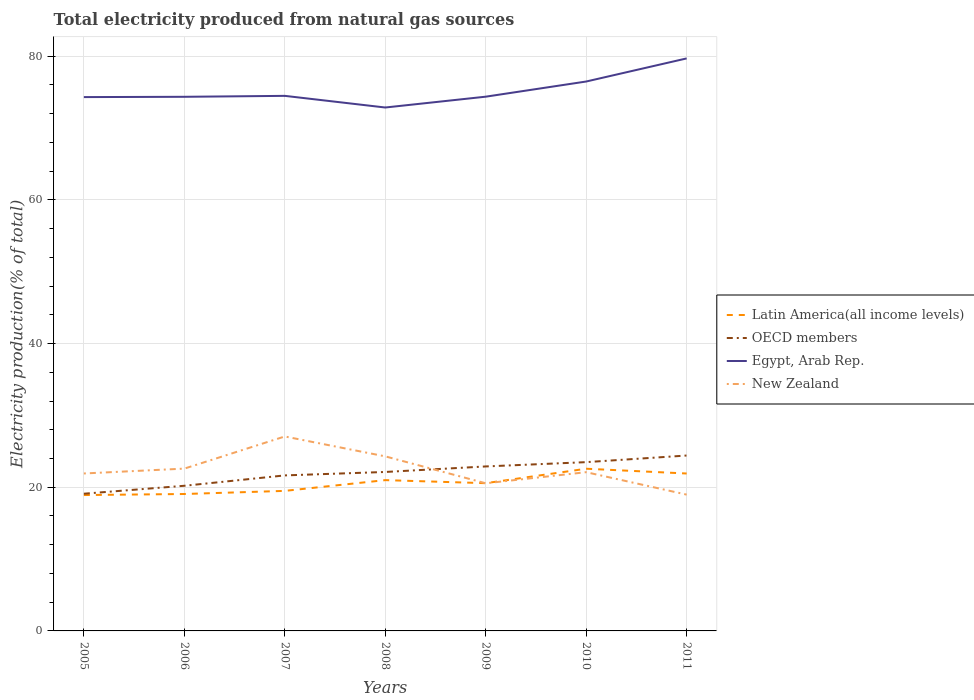Does the line corresponding to OECD members intersect with the line corresponding to Latin America(all income levels)?
Provide a short and direct response. No. Is the number of lines equal to the number of legend labels?
Give a very brief answer. Yes. Across all years, what is the maximum total electricity produced in OECD members?
Provide a succinct answer. 19.1. What is the total total electricity produced in New Zealand in the graph?
Offer a terse response. 2.77. What is the difference between the highest and the second highest total electricity produced in New Zealand?
Offer a terse response. 8.1. What is the difference between the highest and the lowest total electricity produced in Egypt, Arab Rep.?
Keep it short and to the point. 2. How many years are there in the graph?
Your response must be concise. 7. What is the difference between two consecutive major ticks on the Y-axis?
Offer a terse response. 20. Does the graph contain any zero values?
Provide a short and direct response. No. Where does the legend appear in the graph?
Make the answer very short. Center right. How many legend labels are there?
Provide a succinct answer. 4. What is the title of the graph?
Offer a very short reply. Total electricity produced from natural gas sources. Does "Hungary" appear as one of the legend labels in the graph?
Ensure brevity in your answer.  No. What is the label or title of the X-axis?
Provide a succinct answer. Years. What is the label or title of the Y-axis?
Give a very brief answer. Electricity production(% of total). What is the Electricity production(% of total) of Latin America(all income levels) in 2005?
Your answer should be compact. 18.91. What is the Electricity production(% of total) in OECD members in 2005?
Give a very brief answer. 19.1. What is the Electricity production(% of total) in Egypt, Arab Rep. in 2005?
Provide a short and direct response. 74.31. What is the Electricity production(% of total) in New Zealand in 2005?
Your answer should be compact. 21.92. What is the Electricity production(% of total) of Latin America(all income levels) in 2006?
Offer a terse response. 19.06. What is the Electricity production(% of total) of OECD members in 2006?
Offer a very short reply. 20.2. What is the Electricity production(% of total) of Egypt, Arab Rep. in 2006?
Keep it short and to the point. 74.35. What is the Electricity production(% of total) in New Zealand in 2006?
Ensure brevity in your answer.  22.59. What is the Electricity production(% of total) in Latin America(all income levels) in 2007?
Ensure brevity in your answer.  19.49. What is the Electricity production(% of total) in OECD members in 2007?
Your response must be concise. 21.65. What is the Electricity production(% of total) in Egypt, Arab Rep. in 2007?
Your response must be concise. 74.48. What is the Electricity production(% of total) of New Zealand in 2007?
Offer a terse response. 27.07. What is the Electricity production(% of total) in Latin America(all income levels) in 2008?
Ensure brevity in your answer.  20.99. What is the Electricity production(% of total) of OECD members in 2008?
Provide a succinct answer. 22.13. What is the Electricity production(% of total) of Egypt, Arab Rep. in 2008?
Your answer should be very brief. 72.86. What is the Electricity production(% of total) of New Zealand in 2008?
Offer a very short reply. 24.3. What is the Electricity production(% of total) of Latin America(all income levels) in 2009?
Provide a succinct answer. 20.57. What is the Electricity production(% of total) in OECD members in 2009?
Make the answer very short. 22.9. What is the Electricity production(% of total) in Egypt, Arab Rep. in 2009?
Provide a succinct answer. 74.37. What is the Electricity production(% of total) of New Zealand in 2009?
Provide a short and direct response. 20.55. What is the Electricity production(% of total) of Latin America(all income levels) in 2010?
Make the answer very short. 22.58. What is the Electricity production(% of total) in OECD members in 2010?
Your answer should be very brief. 23.49. What is the Electricity production(% of total) of Egypt, Arab Rep. in 2010?
Provide a succinct answer. 76.48. What is the Electricity production(% of total) of New Zealand in 2010?
Offer a terse response. 22.1. What is the Electricity production(% of total) in Latin America(all income levels) in 2011?
Keep it short and to the point. 21.91. What is the Electricity production(% of total) of OECD members in 2011?
Keep it short and to the point. 24.42. What is the Electricity production(% of total) in Egypt, Arab Rep. in 2011?
Keep it short and to the point. 79.69. What is the Electricity production(% of total) of New Zealand in 2011?
Keep it short and to the point. 18.97. Across all years, what is the maximum Electricity production(% of total) in Latin America(all income levels)?
Keep it short and to the point. 22.58. Across all years, what is the maximum Electricity production(% of total) of OECD members?
Your answer should be compact. 24.42. Across all years, what is the maximum Electricity production(% of total) in Egypt, Arab Rep.?
Ensure brevity in your answer.  79.69. Across all years, what is the maximum Electricity production(% of total) in New Zealand?
Keep it short and to the point. 27.07. Across all years, what is the minimum Electricity production(% of total) in Latin America(all income levels)?
Make the answer very short. 18.91. Across all years, what is the minimum Electricity production(% of total) of OECD members?
Your response must be concise. 19.1. Across all years, what is the minimum Electricity production(% of total) of Egypt, Arab Rep.?
Keep it short and to the point. 72.86. Across all years, what is the minimum Electricity production(% of total) of New Zealand?
Your response must be concise. 18.97. What is the total Electricity production(% of total) of Latin America(all income levels) in the graph?
Your answer should be compact. 143.51. What is the total Electricity production(% of total) of OECD members in the graph?
Offer a terse response. 153.88. What is the total Electricity production(% of total) of Egypt, Arab Rep. in the graph?
Provide a succinct answer. 526.54. What is the total Electricity production(% of total) in New Zealand in the graph?
Make the answer very short. 157.5. What is the difference between the Electricity production(% of total) of Latin America(all income levels) in 2005 and that in 2006?
Provide a succinct answer. -0.14. What is the difference between the Electricity production(% of total) of OECD members in 2005 and that in 2006?
Provide a succinct answer. -1.11. What is the difference between the Electricity production(% of total) in Egypt, Arab Rep. in 2005 and that in 2006?
Your answer should be compact. -0.04. What is the difference between the Electricity production(% of total) of New Zealand in 2005 and that in 2006?
Make the answer very short. -0.68. What is the difference between the Electricity production(% of total) of Latin America(all income levels) in 2005 and that in 2007?
Give a very brief answer. -0.58. What is the difference between the Electricity production(% of total) of OECD members in 2005 and that in 2007?
Offer a very short reply. -2.55. What is the difference between the Electricity production(% of total) in Egypt, Arab Rep. in 2005 and that in 2007?
Offer a very short reply. -0.17. What is the difference between the Electricity production(% of total) in New Zealand in 2005 and that in 2007?
Keep it short and to the point. -5.15. What is the difference between the Electricity production(% of total) in Latin America(all income levels) in 2005 and that in 2008?
Offer a very short reply. -2.08. What is the difference between the Electricity production(% of total) in OECD members in 2005 and that in 2008?
Give a very brief answer. -3.03. What is the difference between the Electricity production(% of total) in Egypt, Arab Rep. in 2005 and that in 2008?
Keep it short and to the point. 1.45. What is the difference between the Electricity production(% of total) in New Zealand in 2005 and that in 2008?
Offer a very short reply. -2.38. What is the difference between the Electricity production(% of total) of Latin America(all income levels) in 2005 and that in 2009?
Keep it short and to the point. -1.65. What is the difference between the Electricity production(% of total) of OECD members in 2005 and that in 2009?
Your answer should be very brief. -3.8. What is the difference between the Electricity production(% of total) of Egypt, Arab Rep. in 2005 and that in 2009?
Provide a succinct answer. -0.06. What is the difference between the Electricity production(% of total) of New Zealand in 2005 and that in 2009?
Ensure brevity in your answer.  1.37. What is the difference between the Electricity production(% of total) in Latin America(all income levels) in 2005 and that in 2010?
Your answer should be compact. -3.66. What is the difference between the Electricity production(% of total) of OECD members in 2005 and that in 2010?
Offer a very short reply. -4.4. What is the difference between the Electricity production(% of total) in Egypt, Arab Rep. in 2005 and that in 2010?
Your answer should be compact. -2.17. What is the difference between the Electricity production(% of total) in New Zealand in 2005 and that in 2010?
Offer a terse response. -0.18. What is the difference between the Electricity production(% of total) in Latin America(all income levels) in 2005 and that in 2011?
Give a very brief answer. -3. What is the difference between the Electricity production(% of total) in OECD members in 2005 and that in 2011?
Make the answer very short. -5.32. What is the difference between the Electricity production(% of total) of Egypt, Arab Rep. in 2005 and that in 2011?
Keep it short and to the point. -5.39. What is the difference between the Electricity production(% of total) in New Zealand in 2005 and that in 2011?
Your answer should be very brief. 2.94. What is the difference between the Electricity production(% of total) of Latin America(all income levels) in 2006 and that in 2007?
Give a very brief answer. -0.43. What is the difference between the Electricity production(% of total) of OECD members in 2006 and that in 2007?
Provide a succinct answer. -1.44. What is the difference between the Electricity production(% of total) of Egypt, Arab Rep. in 2006 and that in 2007?
Ensure brevity in your answer.  -0.13. What is the difference between the Electricity production(% of total) in New Zealand in 2006 and that in 2007?
Your response must be concise. -4.47. What is the difference between the Electricity production(% of total) in Latin America(all income levels) in 2006 and that in 2008?
Your answer should be compact. -1.93. What is the difference between the Electricity production(% of total) in OECD members in 2006 and that in 2008?
Provide a short and direct response. -1.92. What is the difference between the Electricity production(% of total) of Egypt, Arab Rep. in 2006 and that in 2008?
Keep it short and to the point. 1.49. What is the difference between the Electricity production(% of total) in New Zealand in 2006 and that in 2008?
Provide a short and direct response. -1.71. What is the difference between the Electricity production(% of total) of Latin America(all income levels) in 2006 and that in 2009?
Your response must be concise. -1.51. What is the difference between the Electricity production(% of total) in OECD members in 2006 and that in 2009?
Offer a very short reply. -2.69. What is the difference between the Electricity production(% of total) of Egypt, Arab Rep. in 2006 and that in 2009?
Your answer should be compact. -0.02. What is the difference between the Electricity production(% of total) of New Zealand in 2006 and that in 2009?
Offer a very short reply. 2.04. What is the difference between the Electricity production(% of total) of Latin America(all income levels) in 2006 and that in 2010?
Your answer should be compact. -3.52. What is the difference between the Electricity production(% of total) of OECD members in 2006 and that in 2010?
Your answer should be very brief. -3.29. What is the difference between the Electricity production(% of total) in Egypt, Arab Rep. in 2006 and that in 2010?
Your answer should be very brief. -2.13. What is the difference between the Electricity production(% of total) in New Zealand in 2006 and that in 2010?
Your response must be concise. 0.5. What is the difference between the Electricity production(% of total) of Latin America(all income levels) in 2006 and that in 2011?
Provide a short and direct response. -2.85. What is the difference between the Electricity production(% of total) in OECD members in 2006 and that in 2011?
Give a very brief answer. -4.21. What is the difference between the Electricity production(% of total) in Egypt, Arab Rep. in 2006 and that in 2011?
Provide a short and direct response. -5.34. What is the difference between the Electricity production(% of total) of New Zealand in 2006 and that in 2011?
Ensure brevity in your answer.  3.62. What is the difference between the Electricity production(% of total) in Latin America(all income levels) in 2007 and that in 2008?
Provide a short and direct response. -1.5. What is the difference between the Electricity production(% of total) of OECD members in 2007 and that in 2008?
Keep it short and to the point. -0.48. What is the difference between the Electricity production(% of total) in Egypt, Arab Rep. in 2007 and that in 2008?
Provide a short and direct response. 1.62. What is the difference between the Electricity production(% of total) of New Zealand in 2007 and that in 2008?
Keep it short and to the point. 2.77. What is the difference between the Electricity production(% of total) in Latin America(all income levels) in 2007 and that in 2009?
Offer a terse response. -1.07. What is the difference between the Electricity production(% of total) in OECD members in 2007 and that in 2009?
Your response must be concise. -1.25. What is the difference between the Electricity production(% of total) of Egypt, Arab Rep. in 2007 and that in 2009?
Make the answer very short. 0.11. What is the difference between the Electricity production(% of total) in New Zealand in 2007 and that in 2009?
Give a very brief answer. 6.52. What is the difference between the Electricity production(% of total) in Latin America(all income levels) in 2007 and that in 2010?
Offer a terse response. -3.08. What is the difference between the Electricity production(% of total) of OECD members in 2007 and that in 2010?
Keep it short and to the point. -1.85. What is the difference between the Electricity production(% of total) of Egypt, Arab Rep. in 2007 and that in 2010?
Provide a succinct answer. -2. What is the difference between the Electricity production(% of total) in New Zealand in 2007 and that in 2010?
Provide a succinct answer. 4.97. What is the difference between the Electricity production(% of total) in Latin America(all income levels) in 2007 and that in 2011?
Provide a succinct answer. -2.42. What is the difference between the Electricity production(% of total) of OECD members in 2007 and that in 2011?
Make the answer very short. -2.77. What is the difference between the Electricity production(% of total) in Egypt, Arab Rep. in 2007 and that in 2011?
Keep it short and to the point. -5.21. What is the difference between the Electricity production(% of total) of New Zealand in 2007 and that in 2011?
Provide a short and direct response. 8.1. What is the difference between the Electricity production(% of total) in Latin America(all income levels) in 2008 and that in 2009?
Give a very brief answer. 0.42. What is the difference between the Electricity production(% of total) of OECD members in 2008 and that in 2009?
Keep it short and to the point. -0.77. What is the difference between the Electricity production(% of total) in Egypt, Arab Rep. in 2008 and that in 2009?
Keep it short and to the point. -1.51. What is the difference between the Electricity production(% of total) of New Zealand in 2008 and that in 2009?
Provide a succinct answer. 3.75. What is the difference between the Electricity production(% of total) of Latin America(all income levels) in 2008 and that in 2010?
Offer a terse response. -1.59. What is the difference between the Electricity production(% of total) of OECD members in 2008 and that in 2010?
Offer a terse response. -1.37. What is the difference between the Electricity production(% of total) of Egypt, Arab Rep. in 2008 and that in 2010?
Make the answer very short. -3.62. What is the difference between the Electricity production(% of total) of New Zealand in 2008 and that in 2010?
Keep it short and to the point. 2.2. What is the difference between the Electricity production(% of total) of Latin America(all income levels) in 2008 and that in 2011?
Provide a short and direct response. -0.92. What is the difference between the Electricity production(% of total) in OECD members in 2008 and that in 2011?
Provide a short and direct response. -2.29. What is the difference between the Electricity production(% of total) in Egypt, Arab Rep. in 2008 and that in 2011?
Offer a terse response. -6.83. What is the difference between the Electricity production(% of total) of New Zealand in 2008 and that in 2011?
Offer a very short reply. 5.33. What is the difference between the Electricity production(% of total) of Latin America(all income levels) in 2009 and that in 2010?
Your answer should be very brief. -2.01. What is the difference between the Electricity production(% of total) in OECD members in 2009 and that in 2010?
Give a very brief answer. -0.6. What is the difference between the Electricity production(% of total) of Egypt, Arab Rep. in 2009 and that in 2010?
Your answer should be very brief. -2.11. What is the difference between the Electricity production(% of total) in New Zealand in 2009 and that in 2010?
Your answer should be compact. -1.55. What is the difference between the Electricity production(% of total) of Latin America(all income levels) in 2009 and that in 2011?
Give a very brief answer. -1.35. What is the difference between the Electricity production(% of total) of OECD members in 2009 and that in 2011?
Your response must be concise. -1.52. What is the difference between the Electricity production(% of total) of Egypt, Arab Rep. in 2009 and that in 2011?
Your response must be concise. -5.33. What is the difference between the Electricity production(% of total) of New Zealand in 2009 and that in 2011?
Your answer should be very brief. 1.58. What is the difference between the Electricity production(% of total) in Latin America(all income levels) in 2010 and that in 2011?
Provide a succinct answer. 0.66. What is the difference between the Electricity production(% of total) of OECD members in 2010 and that in 2011?
Your answer should be compact. -0.92. What is the difference between the Electricity production(% of total) of Egypt, Arab Rep. in 2010 and that in 2011?
Give a very brief answer. -3.22. What is the difference between the Electricity production(% of total) in New Zealand in 2010 and that in 2011?
Offer a terse response. 3.12. What is the difference between the Electricity production(% of total) of Latin America(all income levels) in 2005 and the Electricity production(% of total) of OECD members in 2006?
Provide a succinct answer. -1.29. What is the difference between the Electricity production(% of total) of Latin America(all income levels) in 2005 and the Electricity production(% of total) of Egypt, Arab Rep. in 2006?
Keep it short and to the point. -55.44. What is the difference between the Electricity production(% of total) in Latin America(all income levels) in 2005 and the Electricity production(% of total) in New Zealand in 2006?
Your answer should be very brief. -3.68. What is the difference between the Electricity production(% of total) in OECD members in 2005 and the Electricity production(% of total) in Egypt, Arab Rep. in 2006?
Your response must be concise. -55.25. What is the difference between the Electricity production(% of total) in OECD members in 2005 and the Electricity production(% of total) in New Zealand in 2006?
Offer a terse response. -3.49. What is the difference between the Electricity production(% of total) in Egypt, Arab Rep. in 2005 and the Electricity production(% of total) in New Zealand in 2006?
Make the answer very short. 51.72. What is the difference between the Electricity production(% of total) in Latin America(all income levels) in 2005 and the Electricity production(% of total) in OECD members in 2007?
Ensure brevity in your answer.  -2.73. What is the difference between the Electricity production(% of total) in Latin America(all income levels) in 2005 and the Electricity production(% of total) in Egypt, Arab Rep. in 2007?
Provide a short and direct response. -55.57. What is the difference between the Electricity production(% of total) in Latin America(all income levels) in 2005 and the Electricity production(% of total) in New Zealand in 2007?
Your answer should be compact. -8.15. What is the difference between the Electricity production(% of total) in OECD members in 2005 and the Electricity production(% of total) in Egypt, Arab Rep. in 2007?
Make the answer very short. -55.38. What is the difference between the Electricity production(% of total) of OECD members in 2005 and the Electricity production(% of total) of New Zealand in 2007?
Offer a very short reply. -7.97. What is the difference between the Electricity production(% of total) in Egypt, Arab Rep. in 2005 and the Electricity production(% of total) in New Zealand in 2007?
Offer a very short reply. 47.24. What is the difference between the Electricity production(% of total) of Latin America(all income levels) in 2005 and the Electricity production(% of total) of OECD members in 2008?
Your answer should be compact. -3.21. What is the difference between the Electricity production(% of total) in Latin America(all income levels) in 2005 and the Electricity production(% of total) in Egypt, Arab Rep. in 2008?
Offer a very short reply. -53.94. What is the difference between the Electricity production(% of total) in Latin America(all income levels) in 2005 and the Electricity production(% of total) in New Zealand in 2008?
Your answer should be compact. -5.38. What is the difference between the Electricity production(% of total) of OECD members in 2005 and the Electricity production(% of total) of Egypt, Arab Rep. in 2008?
Make the answer very short. -53.76. What is the difference between the Electricity production(% of total) of OECD members in 2005 and the Electricity production(% of total) of New Zealand in 2008?
Keep it short and to the point. -5.2. What is the difference between the Electricity production(% of total) in Egypt, Arab Rep. in 2005 and the Electricity production(% of total) in New Zealand in 2008?
Provide a short and direct response. 50.01. What is the difference between the Electricity production(% of total) in Latin America(all income levels) in 2005 and the Electricity production(% of total) in OECD members in 2009?
Make the answer very short. -3.98. What is the difference between the Electricity production(% of total) in Latin America(all income levels) in 2005 and the Electricity production(% of total) in Egypt, Arab Rep. in 2009?
Keep it short and to the point. -55.45. What is the difference between the Electricity production(% of total) in Latin America(all income levels) in 2005 and the Electricity production(% of total) in New Zealand in 2009?
Make the answer very short. -1.64. What is the difference between the Electricity production(% of total) of OECD members in 2005 and the Electricity production(% of total) of Egypt, Arab Rep. in 2009?
Give a very brief answer. -55.27. What is the difference between the Electricity production(% of total) in OECD members in 2005 and the Electricity production(% of total) in New Zealand in 2009?
Give a very brief answer. -1.45. What is the difference between the Electricity production(% of total) in Egypt, Arab Rep. in 2005 and the Electricity production(% of total) in New Zealand in 2009?
Offer a very short reply. 53.76. What is the difference between the Electricity production(% of total) in Latin America(all income levels) in 2005 and the Electricity production(% of total) in OECD members in 2010?
Provide a succinct answer. -4.58. What is the difference between the Electricity production(% of total) of Latin America(all income levels) in 2005 and the Electricity production(% of total) of Egypt, Arab Rep. in 2010?
Keep it short and to the point. -57.56. What is the difference between the Electricity production(% of total) in Latin America(all income levels) in 2005 and the Electricity production(% of total) in New Zealand in 2010?
Ensure brevity in your answer.  -3.18. What is the difference between the Electricity production(% of total) of OECD members in 2005 and the Electricity production(% of total) of Egypt, Arab Rep. in 2010?
Give a very brief answer. -57.38. What is the difference between the Electricity production(% of total) in OECD members in 2005 and the Electricity production(% of total) in New Zealand in 2010?
Ensure brevity in your answer.  -3. What is the difference between the Electricity production(% of total) of Egypt, Arab Rep. in 2005 and the Electricity production(% of total) of New Zealand in 2010?
Make the answer very short. 52.21. What is the difference between the Electricity production(% of total) of Latin America(all income levels) in 2005 and the Electricity production(% of total) of OECD members in 2011?
Keep it short and to the point. -5.5. What is the difference between the Electricity production(% of total) in Latin America(all income levels) in 2005 and the Electricity production(% of total) in Egypt, Arab Rep. in 2011?
Provide a short and direct response. -60.78. What is the difference between the Electricity production(% of total) of Latin America(all income levels) in 2005 and the Electricity production(% of total) of New Zealand in 2011?
Give a very brief answer. -0.06. What is the difference between the Electricity production(% of total) in OECD members in 2005 and the Electricity production(% of total) in Egypt, Arab Rep. in 2011?
Offer a very short reply. -60.59. What is the difference between the Electricity production(% of total) of OECD members in 2005 and the Electricity production(% of total) of New Zealand in 2011?
Offer a very short reply. 0.13. What is the difference between the Electricity production(% of total) in Egypt, Arab Rep. in 2005 and the Electricity production(% of total) in New Zealand in 2011?
Make the answer very short. 55.34. What is the difference between the Electricity production(% of total) of Latin America(all income levels) in 2006 and the Electricity production(% of total) of OECD members in 2007?
Give a very brief answer. -2.59. What is the difference between the Electricity production(% of total) in Latin America(all income levels) in 2006 and the Electricity production(% of total) in Egypt, Arab Rep. in 2007?
Give a very brief answer. -55.42. What is the difference between the Electricity production(% of total) in Latin America(all income levels) in 2006 and the Electricity production(% of total) in New Zealand in 2007?
Give a very brief answer. -8.01. What is the difference between the Electricity production(% of total) of OECD members in 2006 and the Electricity production(% of total) of Egypt, Arab Rep. in 2007?
Ensure brevity in your answer.  -54.28. What is the difference between the Electricity production(% of total) of OECD members in 2006 and the Electricity production(% of total) of New Zealand in 2007?
Offer a very short reply. -6.86. What is the difference between the Electricity production(% of total) of Egypt, Arab Rep. in 2006 and the Electricity production(% of total) of New Zealand in 2007?
Keep it short and to the point. 47.28. What is the difference between the Electricity production(% of total) of Latin America(all income levels) in 2006 and the Electricity production(% of total) of OECD members in 2008?
Ensure brevity in your answer.  -3.07. What is the difference between the Electricity production(% of total) in Latin America(all income levels) in 2006 and the Electricity production(% of total) in Egypt, Arab Rep. in 2008?
Provide a short and direct response. -53.8. What is the difference between the Electricity production(% of total) in Latin America(all income levels) in 2006 and the Electricity production(% of total) in New Zealand in 2008?
Offer a very short reply. -5.24. What is the difference between the Electricity production(% of total) in OECD members in 2006 and the Electricity production(% of total) in Egypt, Arab Rep. in 2008?
Ensure brevity in your answer.  -52.66. What is the difference between the Electricity production(% of total) of OECD members in 2006 and the Electricity production(% of total) of New Zealand in 2008?
Keep it short and to the point. -4.09. What is the difference between the Electricity production(% of total) of Egypt, Arab Rep. in 2006 and the Electricity production(% of total) of New Zealand in 2008?
Your answer should be compact. 50.05. What is the difference between the Electricity production(% of total) in Latin America(all income levels) in 2006 and the Electricity production(% of total) in OECD members in 2009?
Keep it short and to the point. -3.84. What is the difference between the Electricity production(% of total) in Latin America(all income levels) in 2006 and the Electricity production(% of total) in Egypt, Arab Rep. in 2009?
Your response must be concise. -55.31. What is the difference between the Electricity production(% of total) of Latin America(all income levels) in 2006 and the Electricity production(% of total) of New Zealand in 2009?
Offer a terse response. -1.49. What is the difference between the Electricity production(% of total) of OECD members in 2006 and the Electricity production(% of total) of Egypt, Arab Rep. in 2009?
Offer a terse response. -54.16. What is the difference between the Electricity production(% of total) in OECD members in 2006 and the Electricity production(% of total) in New Zealand in 2009?
Your response must be concise. -0.35. What is the difference between the Electricity production(% of total) of Egypt, Arab Rep. in 2006 and the Electricity production(% of total) of New Zealand in 2009?
Ensure brevity in your answer.  53.8. What is the difference between the Electricity production(% of total) in Latin America(all income levels) in 2006 and the Electricity production(% of total) in OECD members in 2010?
Make the answer very short. -4.43. What is the difference between the Electricity production(% of total) in Latin America(all income levels) in 2006 and the Electricity production(% of total) in Egypt, Arab Rep. in 2010?
Keep it short and to the point. -57.42. What is the difference between the Electricity production(% of total) of Latin America(all income levels) in 2006 and the Electricity production(% of total) of New Zealand in 2010?
Give a very brief answer. -3.04. What is the difference between the Electricity production(% of total) in OECD members in 2006 and the Electricity production(% of total) in Egypt, Arab Rep. in 2010?
Your response must be concise. -56.27. What is the difference between the Electricity production(% of total) in OECD members in 2006 and the Electricity production(% of total) in New Zealand in 2010?
Make the answer very short. -1.89. What is the difference between the Electricity production(% of total) of Egypt, Arab Rep. in 2006 and the Electricity production(% of total) of New Zealand in 2010?
Give a very brief answer. 52.25. What is the difference between the Electricity production(% of total) of Latin America(all income levels) in 2006 and the Electricity production(% of total) of OECD members in 2011?
Keep it short and to the point. -5.36. What is the difference between the Electricity production(% of total) in Latin America(all income levels) in 2006 and the Electricity production(% of total) in Egypt, Arab Rep. in 2011?
Provide a short and direct response. -60.63. What is the difference between the Electricity production(% of total) in Latin America(all income levels) in 2006 and the Electricity production(% of total) in New Zealand in 2011?
Your answer should be compact. 0.09. What is the difference between the Electricity production(% of total) of OECD members in 2006 and the Electricity production(% of total) of Egypt, Arab Rep. in 2011?
Provide a succinct answer. -59.49. What is the difference between the Electricity production(% of total) in OECD members in 2006 and the Electricity production(% of total) in New Zealand in 2011?
Offer a terse response. 1.23. What is the difference between the Electricity production(% of total) of Egypt, Arab Rep. in 2006 and the Electricity production(% of total) of New Zealand in 2011?
Make the answer very short. 55.38. What is the difference between the Electricity production(% of total) in Latin America(all income levels) in 2007 and the Electricity production(% of total) in OECD members in 2008?
Keep it short and to the point. -2.63. What is the difference between the Electricity production(% of total) of Latin America(all income levels) in 2007 and the Electricity production(% of total) of Egypt, Arab Rep. in 2008?
Give a very brief answer. -53.37. What is the difference between the Electricity production(% of total) of Latin America(all income levels) in 2007 and the Electricity production(% of total) of New Zealand in 2008?
Your answer should be very brief. -4.81. What is the difference between the Electricity production(% of total) of OECD members in 2007 and the Electricity production(% of total) of Egypt, Arab Rep. in 2008?
Give a very brief answer. -51.21. What is the difference between the Electricity production(% of total) in OECD members in 2007 and the Electricity production(% of total) in New Zealand in 2008?
Make the answer very short. -2.65. What is the difference between the Electricity production(% of total) of Egypt, Arab Rep. in 2007 and the Electricity production(% of total) of New Zealand in 2008?
Give a very brief answer. 50.18. What is the difference between the Electricity production(% of total) of Latin America(all income levels) in 2007 and the Electricity production(% of total) of OECD members in 2009?
Your response must be concise. -3.4. What is the difference between the Electricity production(% of total) in Latin America(all income levels) in 2007 and the Electricity production(% of total) in Egypt, Arab Rep. in 2009?
Your answer should be compact. -54.87. What is the difference between the Electricity production(% of total) of Latin America(all income levels) in 2007 and the Electricity production(% of total) of New Zealand in 2009?
Provide a succinct answer. -1.06. What is the difference between the Electricity production(% of total) in OECD members in 2007 and the Electricity production(% of total) in Egypt, Arab Rep. in 2009?
Keep it short and to the point. -52.72. What is the difference between the Electricity production(% of total) in OECD members in 2007 and the Electricity production(% of total) in New Zealand in 2009?
Provide a short and direct response. 1.1. What is the difference between the Electricity production(% of total) in Egypt, Arab Rep. in 2007 and the Electricity production(% of total) in New Zealand in 2009?
Your answer should be very brief. 53.93. What is the difference between the Electricity production(% of total) of Latin America(all income levels) in 2007 and the Electricity production(% of total) of OECD members in 2010?
Make the answer very short. -4. What is the difference between the Electricity production(% of total) of Latin America(all income levels) in 2007 and the Electricity production(% of total) of Egypt, Arab Rep. in 2010?
Offer a terse response. -56.98. What is the difference between the Electricity production(% of total) of Latin America(all income levels) in 2007 and the Electricity production(% of total) of New Zealand in 2010?
Your answer should be very brief. -2.6. What is the difference between the Electricity production(% of total) in OECD members in 2007 and the Electricity production(% of total) in Egypt, Arab Rep. in 2010?
Your answer should be compact. -54.83. What is the difference between the Electricity production(% of total) in OECD members in 2007 and the Electricity production(% of total) in New Zealand in 2010?
Your answer should be very brief. -0.45. What is the difference between the Electricity production(% of total) in Egypt, Arab Rep. in 2007 and the Electricity production(% of total) in New Zealand in 2010?
Offer a terse response. 52.38. What is the difference between the Electricity production(% of total) of Latin America(all income levels) in 2007 and the Electricity production(% of total) of OECD members in 2011?
Give a very brief answer. -4.92. What is the difference between the Electricity production(% of total) in Latin America(all income levels) in 2007 and the Electricity production(% of total) in Egypt, Arab Rep. in 2011?
Give a very brief answer. -60.2. What is the difference between the Electricity production(% of total) in Latin America(all income levels) in 2007 and the Electricity production(% of total) in New Zealand in 2011?
Provide a short and direct response. 0.52. What is the difference between the Electricity production(% of total) of OECD members in 2007 and the Electricity production(% of total) of Egypt, Arab Rep. in 2011?
Provide a succinct answer. -58.05. What is the difference between the Electricity production(% of total) in OECD members in 2007 and the Electricity production(% of total) in New Zealand in 2011?
Your answer should be very brief. 2.68. What is the difference between the Electricity production(% of total) of Egypt, Arab Rep. in 2007 and the Electricity production(% of total) of New Zealand in 2011?
Your answer should be very brief. 55.51. What is the difference between the Electricity production(% of total) in Latin America(all income levels) in 2008 and the Electricity production(% of total) in OECD members in 2009?
Your answer should be very brief. -1.91. What is the difference between the Electricity production(% of total) of Latin America(all income levels) in 2008 and the Electricity production(% of total) of Egypt, Arab Rep. in 2009?
Offer a terse response. -53.38. What is the difference between the Electricity production(% of total) of Latin America(all income levels) in 2008 and the Electricity production(% of total) of New Zealand in 2009?
Your response must be concise. 0.44. What is the difference between the Electricity production(% of total) of OECD members in 2008 and the Electricity production(% of total) of Egypt, Arab Rep. in 2009?
Give a very brief answer. -52.24. What is the difference between the Electricity production(% of total) of OECD members in 2008 and the Electricity production(% of total) of New Zealand in 2009?
Make the answer very short. 1.58. What is the difference between the Electricity production(% of total) of Egypt, Arab Rep. in 2008 and the Electricity production(% of total) of New Zealand in 2009?
Give a very brief answer. 52.31. What is the difference between the Electricity production(% of total) in Latin America(all income levels) in 2008 and the Electricity production(% of total) in OECD members in 2010?
Make the answer very short. -2.5. What is the difference between the Electricity production(% of total) in Latin America(all income levels) in 2008 and the Electricity production(% of total) in Egypt, Arab Rep. in 2010?
Your answer should be very brief. -55.49. What is the difference between the Electricity production(% of total) in Latin America(all income levels) in 2008 and the Electricity production(% of total) in New Zealand in 2010?
Your response must be concise. -1.11. What is the difference between the Electricity production(% of total) of OECD members in 2008 and the Electricity production(% of total) of Egypt, Arab Rep. in 2010?
Give a very brief answer. -54.35. What is the difference between the Electricity production(% of total) in OECD members in 2008 and the Electricity production(% of total) in New Zealand in 2010?
Ensure brevity in your answer.  0.03. What is the difference between the Electricity production(% of total) in Egypt, Arab Rep. in 2008 and the Electricity production(% of total) in New Zealand in 2010?
Offer a terse response. 50.76. What is the difference between the Electricity production(% of total) in Latin America(all income levels) in 2008 and the Electricity production(% of total) in OECD members in 2011?
Keep it short and to the point. -3.43. What is the difference between the Electricity production(% of total) of Latin America(all income levels) in 2008 and the Electricity production(% of total) of Egypt, Arab Rep. in 2011?
Give a very brief answer. -58.7. What is the difference between the Electricity production(% of total) in Latin America(all income levels) in 2008 and the Electricity production(% of total) in New Zealand in 2011?
Keep it short and to the point. 2.02. What is the difference between the Electricity production(% of total) in OECD members in 2008 and the Electricity production(% of total) in Egypt, Arab Rep. in 2011?
Provide a short and direct response. -57.57. What is the difference between the Electricity production(% of total) of OECD members in 2008 and the Electricity production(% of total) of New Zealand in 2011?
Provide a succinct answer. 3.15. What is the difference between the Electricity production(% of total) of Egypt, Arab Rep. in 2008 and the Electricity production(% of total) of New Zealand in 2011?
Your response must be concise. 53.89. What is the difference between the Electricity production(% of total) of Latin America(all income levels) in 2009 and the Electricity production(% of total) of OECD members in 2010?
Your answer should be very brief. -2.93. What is the difference between the Electricity production(% of total) in Latin America(all income levels) in 2009 and the Electricity production(% of total) in Egypt, Arab Rep. in 2010?
Ensure brevity in your answer.  -55.91. What is the difference between the Electricity production(% of total) in Latin America(all income levels) in 2009 and the Electricity production(% of total) in New Zealand in 2010?
Offer a terse response. -1.53. What is the difference between the Electricity production(% of total) in OECD members in 2009 and the Electricity production(% of total) in Egypt, Arab Rep. in 2010?
Offer a very short reply. -53.58. What is the difference between the Electricity production(% of total) in OECD members in 2009 and the Electricity production(% of total) in New Zealand in 2010?
Keep it short and to the point. 0.8. What is the difference between the Electricity production(% of total) of Egypt, Arab Rep. in 2009 and the Electricity production(% of total) of New Zealand in 2010?
Provide a succinct answer. 52.27. What is the difference between the Electricity production(% of total) in Latin America(all income levels) in 2009 and the Electricity production(% of total) in OECD members in 2011?
Offer a very short reply. -3.85. What is the difference between the Electricity production(% of total) in Latin America(all income levels) in 2009 and the Electricity production(% of total) in Egypt, Arab Rep. in 2011?
Your answer should be compact. -59.13. What is the difference between the Electricity production(% of total) of Latin America(all income levels) in 2009 and the Electricity production(% of total) of New Zealand in 2011?
Provide a short and direct response. 1.59. What is the difference between the Electricity production(% of total) in OECD members in 2009 and the Electricity production(% of total) in Egypt, Arab Rep. in 2011?
Give a very brief answer. -56.8. What is the difference between the Electricity production(% of total) in OECD members in 2009 and the Electricity production(% of total) in New Zealand in 2011?
Provide a short and direct response. 3.92. What is the difference between the Electricity production(% of total) in Egypt, Arab Rep. in 2009 and the Electricity production(% of total) in New Zealand in 2011?
Provide a short and direct response. 55.39. What is the difference between the Electricity production(% of total) of Latin America(all income levels) in 2010 and the Electricity production(% of total) of OECD members in 2011?
Offer a terse response. -1.84. What is the difference between the Electricity production(% of total) of Latin America(all income levels) in 2010 and the Electricity production(% of total) of Egypt, Arab Rep. in 2011?
Give a very brief answer. -57.12. What is the difference between the Electricity production(% of total) in Latin America(all income levels) in 2010 and the Electricity production(% of total) in New Zealand in 2011?
Provide a succinct answer. 3.61. What is the difference between the Electricity production(% of total) of OECD members in 2010 and the Electricity production(% of total) of Egypt, Arab Rep. in 2011?
Your response must be concise. -56.2. What is the difference between the Electricity production(% of total) in OECD members in 2010 and the Electricity production(% of total) in New Zealand in 2011?
Your answer should be compact. 4.52. What is the difference between the Electricity production(% of total) of Egypt, Arab Rep. in 2010 and the Electricity production(% of total) of New Zealand in 2011?
Give a very brief answer. 57.5. What is the average Electricity production(% of total) of Latin America(all income levels) per year?
Your answer should be compact. 20.5. What is the average Electricity production(% of total) of OECD members per year?
Provide a succinct answer. 21.98. What is the average Electricity production(% of total) of Egypt, Arab Rep. per year?
Ensure brevity in your answer.  75.22. What is the average Electricity production(% of total) in New Zealand per year?
Give a very brief answer. 22.5. In the year 2005, what is the difference between the Electricity production(% of total) of Latin America(all income levels) and Electricity production(% of total) of OECD members?
Your answer should be very brief. -0.18. In the year 2005, what is the difference between the Electricity production(% of total) in Latin America(all income levels) and Electricity production(% of total) in Egypt, Arab Rep.?
Your answer should be compact. -55.39. In the year 2005, what is the difference between the Electricity production(% of total) in Latin America(all income levels) and Electricity production(% of total) in New Zealand?
Offer a terse response. -3. In the year 2005, what is the difference between the Electricity production(% of total) of OECD members and Electricity production(% of total) of Egypt, Arab Rep.?
Make the answer very short. -55.21. In the year 2005, what is the difference between the Electricity production(% of total) in OECD members and Electricity production(% of total) in New Zealand?
Ensure brevity in your answer.  -2.82. In the year 2005, what is the difference between the Electricity production(% of total) in Egypt, Arab Rep. and Electricity production(% of total) in New Zealand?
Your response must be concise. 52.39. In the year 2006, what is the difference between the Electricity production(% of total) in Latin America(all income levels) and Electricity production(% of total) in OECD members?
Make the answer very short. -1.15. In the year 2006, what is the difference between the Electricity production(% of total) of Latin America(all income levels) and Electricity production(% of total) of Egypt, Arab Rep.?
Keep it short and to the point. -55.29. In the year 2006, what is the difference between the Electricity production(% of total) in Latin America(all income levels) and Electricity production(% of total) in New Zealand?
Ensure brevity in your answer.  -3.53. In the year 2006, what is the difference between the Electricity production(% of total) in OECD members and Electricity production(% of total) in Egypt, Arab Rep.?
Keep it short and to the point. -54.15. In the year 2006, what is the difference between the Electricity production(% of total) in OECD members and Electricity production(% of total) in New Zealand?
Keep it short and to the point. -2.39. In the year 2006, what is the difference between the Electricity production(% of total) of Egypt, Arab Rep. and Electricity production(% of total) of New Zealand?
Give a very brief answer. 51.76. In the year 2007, what is the difference between the Electricity production(% of total) of Latin America(all income levels) and Electricity production(% of total) of OECD members?
Give a very brief answer. -2.15. In the year 2007, what is the difference between the Electricity production(% of total) of Latin America(all income levels) and Electricity production(% of total) of Egypt, Arab Rep.?
Offer a terse response. -54.99. In the year 2007, what is the difference between the Electricity production(% of total) in Latin America(all income levels) and Electricity production(% of total) in New Zealand?
Offer a terse response. -7.57. In the year 2007, what is the difference between the Electricity production(% of total) of OECD members and Electricity production(% of total) of Egypt, Arab Rep.?
Offer a terse response. -52.83. In the year 2007, what is the difference between the Electricity production(% of total) in OECD members and Electricity production(% of total) in New Zealand?
Make the answer very short. -5.42. In the year 2007, what is the difference between the Electricity production(% of total) of Egypt, Arab Rep. and Electricity production(% of total) of New Zealand?
Your response must be concise. 47.41. In the year 2008, what is the difference between the Electricity production(% of total) in Latin America(all income levels) and Electricity production(% of total) in OECD members?
Offer a terse response. -1.14. In the year 2008, what is the difference between the Electricity production(% of total) of Latin America(all income levels) and Electricity production(% of total) of Egypt, Arab Rep.?
Keep it short and to the point. -51.87. In the year 2008, what is the difference between the Electricity production(% of total) of Latin America(all income levels) and Electricity production(% of total) of New Zealand?
Provide a succinct answer. -3.31. In the year 2008, what is the difference between the Electricity production(% of total) of OECD members and Electricity production(% of total) of Egypt, Arab Rep.?
Your response must be concise. -50.73. In the year 2008, what is the difference between the Electricity production(% of total) of OECD members and Electricity production(% of total) of New Zealand?
Offer a terse response. -2.17. In the year 2008, what is the difference between the Electricity production(% of total) in Egypt, Arab Rep. and Electricity production(% of total) in New Zealand?
Keep it short and to the point. 48.56. In the year 2009, what is the difference between the Electricity production(% of total) of Latin America(all income levels) and Electricity production(% of total) of OECD members?
Keep it short and to the point. -2.33. In the year 2009, what is the difference between the Electricity production(% of total) of Latin America(all income levels) and Electricity production(% of total) of Egypt, Arab Rep.?
Make the answer very short. -53.8. In the year 2009, what is the difference between the Electricity production(% of total) of Latin America(all income levels) and Electricity production(% of total) of New Zealand?
Give a very brief answer. 0.01. In the year 2009, what is the difference between the Electricity production(% of total) of OECD members and Electricity production(% of total) of Egypt, Arab Rep.?
Give a very brief answer. -51.47. In the year 2009, what is the difference between the Electricity production(% of total) in OECD members and Electricity production(% of total) in New Zealand?
Give a very brief answer. 2.34. In the year 2009, what is the difference between the Electricity production(% of total) in Egypt, Arab Rep. and Electricity production(% of total) in New Zealand?
Provide a succinct answer. 53.82. In the year 2010, what is the difference between the Electricity production(% of total) of Latin America(all income levels) and Electricity production(% of total) of OECD members?
Offer a terse response. -0.92. In the year 2010, what is the difference between the Electricity production(% of total) in Latin America(all income levels) and Electricity production(% of total) in Egypt, Arab Rep.?
Keep it short and to the point. -53.9. In the year 2010, what is the difference between the Electricity production(% of total) of Latin America(all income levels) and Electricity production(% of total) of New Zealand?
Give a very brief answer. 0.48. In the year 2010, what is the difference between the Electricity production(% of total) in OECD members and Electricity production(% of total) in Egypt, Arab Rep.?
Your answer should be compact. -52.98. In the year 2010, what is the difference between the Electricity production(% of total) in OECD members and Electricity production(% of total) in New Zealand?
Give a very brief answer. 1.4. In the year 2010, what is the difference between the Electricity production(% of total) in Egypt, Arab Rep. and Electricity production(% of total) in New Zealand?
Give a very brief answer. 54.38. In the year 2011, what is the difference between the Electricity production(% of total) of Latin America(all income levels) and Electricity production(% of total) of OECD members?
Offer a terse response. -2.5. In the year 2011, what is the difference between the Electricity production(% of total) of Latin America(all income levels) and Electricity production(% of total) of Egypt, Arab Rep.?
Offer a very short reply. -57.78. In the year 2011, what is the difference between the Electricity production(% of total) of Latin America(all income levels) and Electricity production(% of total) of New Zealand?
Keep it short and to the point. 2.94. In the year 2011, what is the difference between the Electricity production(% of total) of OECD members and Electricity production(% of total) of Egypt, Arab Rep.?
Keep it short and to the point. -55.28. In the year 2011, what is the difference between the Electricity production(% of total) in OECD members and Electricity production(% of total) in New Zealand?
Offer a terse response. 5.44. In the year 2011, what is the difference between the Electricity production(% of total) of Egypt, Arab Rep. and Electricity production(% of total) of New Zealand?
Offer a terse response. 60.72. What is the ratio of the Electricity production(% of total) of OECD members in 2005 to that in 2006?
Keep it short and to the point. 0.95. What is the ratio of the Electricity production(% of total) in New Zealand in 2005 to that in 2006?
Offer a very short reply. 0.97. What is the ratio of the Electricity production(% of total) in Latin America(all income levels) in 2005 to that in 2007?
Give a very brief answer. 0.97. What is the ratio of the Electricity production(% of total) in OECD members in 2005 to that in 2007?
Provide a succinct answer. 0.88. What is the ratio of the Electricity production(% of total) of New Zealand in 2005 to that in 2007?
Ensure brevity in your answer.  0.81. What is the ratio of the Electricity production(% of total) in Latin America(all income levels) in 2005 to that in 2008?
Your answer should be very brief. 0.9. What is the ratio of the Electricity production(% of total) of OECD members in 2005 to that in 2008?
Ensure brevity in your answer.  0.86. What is the ratio of the Electricity production(% of total) of Egypt, Arab Rep. in 2005 to that in 2008?
Your response must be concise. 1.02. What is the ratio of the Electricity production(% of total) of New Zealand in 2005 to that in 2008?
Your answer should be compact. 0.9. What is the ratio of the Electricity production(% of total) of Latin America(all income levels) in 2005 to that in 2009?
Offer a very short reply. 0.92. What is the ratio of the Electricity production(% of total) in OECD members in 2005 to that in 2009?
Provide a short and direct response. 0.83. What is the ratio of the Electricity production(% of total) in New Zealand in 2005 to that in 2009?
Give a very brief answer. 1.07. What is the ratio of the Electricity production(% of total) of Latin America(all income levels) in 2005 to that in 2010?
Your answer should be very brief. 0.84. What is the ratio of the Electricity production(% of total) of OECD members in 2005 to that in 2010?
Your response must be concise. 0.81. What is the ratio of the Electricity production(% of total) in Egypt, Arab Rep. in 2005 to that in 2010?
Offer a very short reply. 0.97. What is the ratio of the Electricity production(% of total) of Latin America(all income levels) in 2005 to that in 2011?
Your answer should be very brief. 0.86. What is the ratio of the Electricity production(% of total) in OECD members in 2005 to that in 2011?
Give a very brief answer. 0.78. What is the ratio of the Electricity production(% of total) in Egypt, Arab Rep. in 2005 to that in 2011?
Your response must be concise. 0.93. What is the ratio of the Electricity production(% of total) in New Zealand in 2005 to that in 2011?
Your response must be concise. 1.16. What is the ratio of the Electricity production(% of total) in Latin America(all income levels) in 2006 to that in 2007?
Offer a very short reply. 0.98. What is the ratio of the Electricity production(% of total) of OECD members in 2006 to that in 2007?
Provide a succinct answer. 0.93. What is the ratio of the Electricity production(% of total) in Egypt, Arab Rep. in 2006 to that in 2007?
Your answer should be compact. 1. What is the ratio of the Electricity production(% of total) in New Zealand in 2006 to that in 2007?
Your answer should be compact. 0.83. What is the ratio of the Electricity production(% of total) in Latin America(all income levels) in 2006 to that in 2008?
Ensure brevity in your answer.  0.91. What is the ratio of the Electricity production(% of total) in OECD members in 2006 to that in 2008?
Provide a short and direct response. 0.91. What is the ratio of the Electricity production(% of total) in Egypt, Arab Rep. in 2006 to that in 2008?
Provide a succinct answer. 1.02. What is the ratio of the Electricity production(% of total) in New Zealand in 2006 to that in 2008?
Keep it short and to the point. 0.93. What is the ratio of the Electricity production(% of total) of Latin America(all income levels) in 2006 to that in 2009?
Give a very brief answer. 0.93. What is the ratio of the Electricity production(% of total) of OECD members in 2006 to that in 2009?
Provide a short and direct response. 0.88. What is the ratio of the Electricity production(% of total) in New Zealand in 2006 to that in 2009?
Give a very brief answer. 1.1. What is the ratio of the Electricity production(% of total) of Latin America(all income levels) in 2006 to that in 2010?
Make the answer very short. 0.84. What is the ratio of the Electricity production(% of total) of OECD members in 2006 to that in 2010?
Ensure brevity in your answer.  0.86. What is the ratio of the Electricity production(% of total) in Egypt, Arab Rep. in 2006 to that in 2010?
Your answer should be compact. 0.97. What is the ratio of the Electricity production(% of total) of New Zealand in 2006 to that in 2010?
Give a very brief answer. 1.02. What is the ratio of the Electricity production(% of total) of Latin America(all income levels) in 2006 to that in 2011?
Your response must be concise. 0.87. What is the ratio of the Electricity production(% of total) in OECD members in 2006 to that in 2011?
Your response must be concise. 0.83. What is the ratio of the Electricity production(% of total) in Egypt, Arab Rep. in 2006 to that in 2011?
Keep it short and to the point. 0.93. What is the ratio of the Electricity production(% of total) in New Zealand in 2006 to that in 2011?
Make the answer very short. 1.19. What is the ratio of the Electricity production(% of total) of Latin America(all income levels) in 2007 to that in 2008?
Offer a terse response. 0.93. What is the ratio of the Electricity production(% of total) in OECD members in 2007 to that in 2008?
Provide a short and direct response. 0.98. What is the ratio of the Electricity production(% of total) of Egypt, Arab Rep. in 2007 to that in 2008?
Provide a succinct answer. 1.02. What is the ratio of the Electricity production(% of total) of New Zealand in 2007 to that in 2008?
Provide a short and direct response. 1.11. What is the ratio of the Electricity production(% of total) of Latin America(all income levels) in 2007 to that in 2009?
Provide a short and direct response. 0.95. What is the ratio of the Electricity production(% of total) of OECD members in 2007 to that in 2009?
Your response must be concise. 0.95. What is the ratio of the Electricity production(% of total) in Egypt, Arab Rep. in 2007 to that in 2009?
Your response must be concise. 1. What is the ratio of the Electricity production(% of total) of New Zealand in 2007 to that in 2009?
Make the answer very short. 1.32. What is the ratio of the Electricity production(% of total) of Latin America(all income levels) in 2007 to that in 2010?
Make the answer very short. 0.86. What is the ratio of the Electricity production(% of total) in OECD members in 2007 to that in 2010?
Your answer should be very brief. 0.92. What is the ratio of the Electricity production(% of total) of Egypt, Arab Rep. in 2007 to that in 2010?
Offer a very short reply. 0.97. What is the ratio of the Electricity production(% of total) of New Zealand in 2007 to that in 2010?
Offer a terse response. 1.23. What is the ratio of the Electricity production(% of total) of Latin America(all income levels) in 2007 to that in 2011?
Make the answer very short. 0.89. What is the ratio of the Electricity production(% of total) of OECD members in 2007 to that in 2011?
Your answer should be very brief. 0.89. What is the ratio of the Electricity production(% of total) of Egypt, Arab Rep. in 2007 to that in 2011?
Your answer should be compact. 0.93. What is the ratio of the Electricity production(% of total) of New Zealand in 2007 to that in 2011?
Your answer should be compact. 1.43. What is the ratio of the Electricity production(% of total) of Latin America(all income levels) in 2008 to that in 2009?
Ensure brevity in your answer.  1.02. What is the ratio of the Electricity production(% of total) of OECD members in 2008 to that in 2009?
Give a very brief answer. 0.97. What is the ratio of the Electricity production(% of total) of Egypt, Arab Rep. in 2008 to that in 2009?
Provide a short and direct response. 0.98. What is the ratio of the Electricity production(% of total) in New Zealand in 2008 to that in 2009?
Your answer should be very brief. 1.18. What is the ratio of the Electricity production(% of total) in Latin America(all income levels) in 2008 to that in 2010?
Your answer should be very brief. 0.93. What is the ratio of the Electricity production(% of total) of OECD members in 2008 to that in 2010?
Make the answer very short. 0.94. What is the ratio of the Electricity production(% of total) of Egypt, Arab Rep. in 2008 to that in 2010?
Provide a short and direct response. 0.95. What is the ratio of the Electricity production(% of total) of New Zealand in 2008 to that in 2010?
Ensure brevity in your answer.  1.1. What is the ratio of the Electricity production(% of total) of Latin America(all income levels) in 2008 to that in 2011?
Give a very brief answer. 0.96. What is the ratio of the Electricity production(% of total) in OECD members in 2008 to that in 2011?
Give a very brief answer. 0.91. What is the ratio of the Electricity production(% of total) of Egypt, Arab Rep. in 2008 to that in 2011?
Provide a short and direct response. 0.91. What is the ratio of the Electricity production(% of total) in New Zealand in 2008 to that in 2011?
Keep it short and to the point. 1.28. What is the ratio of the Electricity production(% of total) of Latin America(all income levels) in 2009 to that in 2010?
Provide a short and direct response. 0.91. What is the ratio of the Electricity production(% of total) of OECD members in 2009 to that in 2010?
Ensure brevity in your answer.  0.97. What is the ratio of the Electricity production(% of total) in Egypt, Arab Rep. in 2009 to that in 2010?
Offer a very short reply. 0.97. What is the ratio of the Electricity production(% of total) of New Zealand in 2009 to that in 2010?
Provide a succinct answer. 0.93. What is the ratio of the Electricity production(% of total) in Latin America(all income levels) in 2009 to that in 2011?
Your response must be concise. 0.94. What is the ratio of the Electricity production(% of total) of OECD members in 2009 to that in 2011?
Your answer should be very brief. 0.94. What is the ratio of the Electricity production(% of total) in Egypt, Arab Rep. in 2009 to that in 2011?
Keep it short and to the point. 0.93. What is the ratio of the Electricity production(% of total) of New Zealand in 2009 to that in 2011?
Your response must be concise. 1.08. What is the ratio of the Electricity production(% of total) in Latin America(all income levels) in 2010 to that in 2011?
Offer a terse response. 1.03. What is the ratio of the Electricity production(% of total) in OECD members in 2010 to that in 2011?
Keep it short and to the point. 0.96. What is the ratio of the Electricity production(% of total) in Egypt, Arab Rep. in 2010 to that in 2011?
Offer a terse response. 0.96. What is the ratio of the Electricity production(% of total) of New Zealand in 2010 to that in 2011?
Provide a short and direct response. 1.16. What is the difference between the highest and the second highest Electricity production(% of total) of Latin America(all income levels)?
Make the answer very short. 0.66. What is the difference between the highest and the second highest Electricity production(% of total) of OECD members?
Offer a terse response. 0.92. What is the difference between the highest and the second highest Electricity production(% of total) of Egypt, Arab Rep.?
Your response must be concise. 3.22. What is the difference between the highest and the second highest Electricity production(% of total) in New Zealand?
Your answer should be compact. 2.77. What is the difference between the highest and the lowest Electricity production(% of total) in Latin America(all income levels)?
Ensure brevity in your answer.  3.66. What is the difference between the highest and the lowest Electricity production(% of total) in OECD members?
Ensure brevity in your answer.  5.32. What is the difference between the highest and the lowest Electricity production(% of total) in Egypt, Arab Rep.?
Your answer should be compact. 6.83. What is the difference between the highest and the lowest Electricity production(% of total) of New Zealand?
Provide a short and direct response. 8.1. 